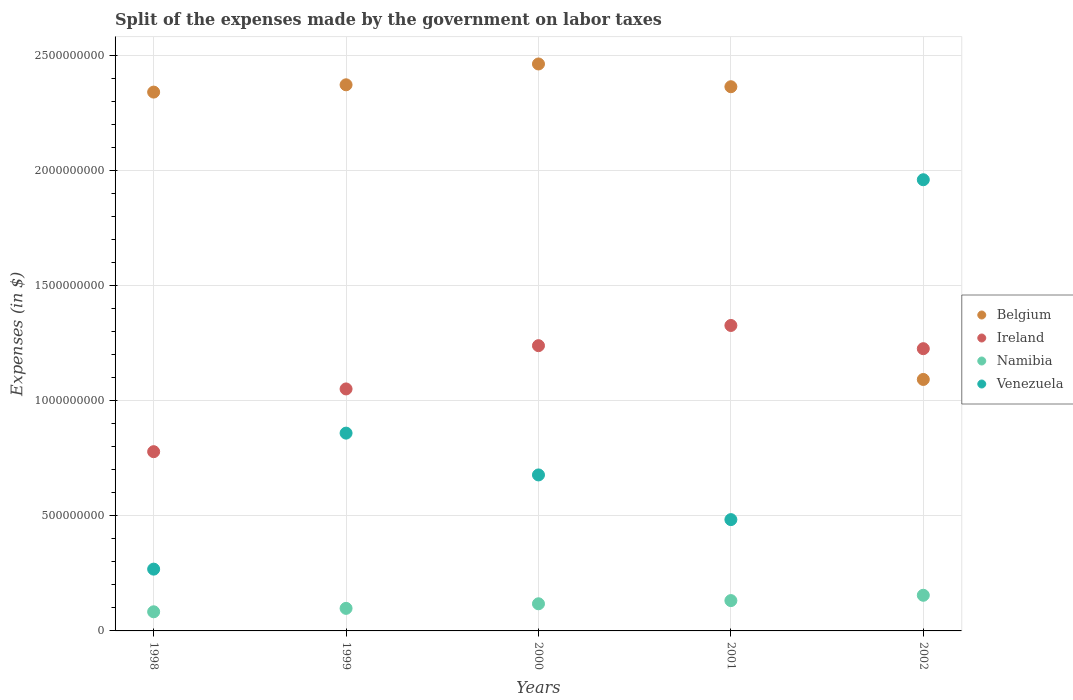Is the number of dotlines equal to the number of legend labels?
Offer a terse response. Yes. What is the expenses made by the government on labor taxes in Ireland in 2002?
Your answer should be compact. 1.23e+09. Across all years, what is the maximum expenses made by the government on labor taxes in Ireland?
Provide a short and direct response. 1.33e+09. Across all years, what is the minimum expenses made by the government on labor taxes in Venezuela?
Provide a succinct answer. 2.68e+08. In which year was the expenses made by the government on labor taxes in Belgium minimum?
Offer a terse response. 2002. What is the total expenses made by the government on labor taxes in Namibia in the graph?
Provide a succinct answer. 5.86e+08. What is the difference between the expenses made by the government on labor taxes in Belgium in 2000 and that in 2001?
Offer a terse response. 9.89e+07. What is the difference between the expenses made by the government on labor taxes in Venezuela in 2002 and the expenses made by the government on labor taxes in Ireland in 1999?
Ensure brevity in your answer.  9.09e+08. What is the average expenses made by the government on labor taxes in Ireland per year?
Offer a very short reply. 1.12e+09. In the year 2002, what is the difference between the expenses made by the government on labor taxes in Ireland and expenses made by the government on labor taxes in Venezuela?
Provide a short and direct response. -7.34e+08. In how many years, is the expenses made by the government on labor taxes in Ireland greater than 100000000 $?
Offer a terse response. 5. What is the ratio of the expenses made by the government on labor taxes in Belgium in 1998 to that in 2000?
Give a very brief answer. 0.95. What is the difference between the highest and the second highest expenses made by the government on labor taxes in Ireland?
Keep it short and to the point. 8.78e+07. What is the difference between the highest and the lowest expenses made by the government on labor taxes in Ireland?
Make the answer very short. 5.48e+08. In how many years, is the expenses made by the government on labor taxes in Namibia greater than the average expenses made by the government on labor taxes in Namibia taken over all years?
Your response must be concise. 3. Is the sum of the expenses made by the government on labor taxes in Belgium in 2001 and 2002 greater than the maximum expenses made by the government on labor taxes in Venezuela across all years?
Make the answer very short. Yes. Is it the case that in every year, the sum of the expenses made by the government on labor taxes in Belgium and expenses made by the government on labor taxes in Namibia  is greater than the sum of expenses made by the government on labor taxes in Venezuela and expenses made by the government on labor taxes in Ireland?
Offer a terse response. Yes. Does the expenses made by the government on labor taxes in Venezuela monotonically increase over the years?
Provide a succinct answer. No. Is the expenses made by the government on labor taxes in Ireland strictly less than the expenses made by the government on labor taxes in Belgium over the years?
Ensure brevity in your answer.  No. How many dotlines are there?
Provide a succinct answer. 4. Does the graph contain grids?
Give a very brief answer. Yes. Where does the legend appear in the graph?
Make the answer very short. Center right. What is the title of the graph?
Your answer should be very brief. Split of the expenses made by the government on labor taxes. What is the label or title of the X-axis?
Keep it short and to the point. Years. What is the label or title of the Y-axis?
Your answer should be compact. Expenses (in $). What is the Expenses (in $) of Belgium in 1998?
Provide a succinct answer. 2.34e+09. What is the Expenses (in $) of Ireland in 1998?
Give a very brief answer. 7.79e+08. What is the Expenses (in $) in Namibia in 1998?
Keep it short and to the point. 8.31e+07. What is the Expenses (in $) of Venezuela in 1998?
Give a very brief answer. 2.68e+08. What is the Expenses (in $) in Belgium in 1999?
Make the answer very short. 2.37e+09. What is the Expenses (in $) of Ireland in 1999?
Provide a short and direct response. 1.05e+09. What is the Expenses (in $) in Namibia in 1999?
Make the answer very short. 9.80e+07. What is the Expenses (in $) in Venezuela in 1999?
Ensure brevity in your answer.  8.59e+08. What is the Expenses (in $) in Belgium in 2000?
Ensure brevity in your answer.  2.46e+09. What is the Expenses (in $) of Ireland in 2000?
Make the answer very short. 1.24e+09. What is the Expenses (in $) in Namibia in 2000?
Offer a very short reply. 1.18e+08. What is the Expenses (in $) in Venezuela in 2000?
Give a very brief answer. 6.78e+08. What is the Expenses (in $) of Belgium in 2001?
Provide a succinct answer. 2.36e+09. What is the Expenses (in $) in Ireland in 2001?
Ensure brevity in your answer.  1.33e+09. What is the Expenses (in $) in Namibia in 2001?
Your answer should be very brief. 1.32e+08. What is the Expenses (in $) in Venezuela in 2001?
Provide a succinct answer. 4.84e+08. What is the Expenses (in $) of Belgium in 2002?
Offer a very short reply. 1.09e+09. What is the Expenses (in $) in Ireland in 2002?
Your answer should be very brief. 1.23e+09. What is the Expenses (in $) of Namibia in 2002?
Your response must be concise. 1.55e+08. What is the Expenses (in $) in Venezuela in 2002?
Make the answer very short. 1.96e+09. Across all years, what is the maximum Expenses (in $) of Belgium?
Provide a short and direct response. 2.46e+09. Across all years, what is the maximum Expenses (in $) of Ireland?
Your answer should be very brief. 1.33e+09. Across all years, what is the maximum Expenses (in $) in Namibia?
Provide a short and direct response. 1.55e+08. Across all years, what is the maximum Expenses (in $) in Venezuela?
Offer a terse response. 1.96e+09. Across all years, what is the minimum Expenses (in $) in Belgium?
Your answer should be compact. 1.09e+09. Across all years, what is the minimum Expenses (in $) in Ireland?
Your answer should be compact. 7.79e+08. Across all years, what is the minimum Expenses (in $) in Namibia?
Provide a short and direct response. 8.31e+07. Across all years, what is the minimum Expenses (in $) of Venezuela?
Provide a short and direct response. 2.68e+08. What is the total Expenses (in $) in Belgium in the graph?
Provide a short and direct response. 1.06e+1. What is the total Expenses (in $) in Ireland in the graph?
Your answer should be compact. 5.62e+09. What is the total Expenses (in $) in Namibia in the graph?
Your response must be concise. 5.86e+08. What is the total Expenses (in $) in Venezuela in the graph?
Give a very brief answer. 4.25e+09. What is the difference between the Expenses (in $) in Belgium in 1998 and that in 1999?
Make the answer very short. -3.17e+07. What is the difference between the Expenses (in $) in Ireland in 1998 and that in 1999?
Make the answer very short. -2.73e+08. What is the difference between the Expenses (in $) in Namibia in 1998 and that in 1999?
Make the answer very short. -1.49e+07. What is the difference between the Expenses (in $) of Venezuela in 1998 and that in 1999?
Ensure brevity in your answer.  -5.91e+08. What is the difference between the Expenses (in $) of Belgium in 1998 and that in 2000?
Keep it short and to the point. -1.22e+08. What is the difference between the Expenses (in $) in Ireland in 1998 and that in 2000?
Your answer should be compact. -4.61e+08. What is the difference between the Expenses (in $) of Namibia in 1998 and that in 2000?
Offer a very short reply. -3.48e+07. What is the difference between the Expenses (in $) of Venezuela in 1998 and that in 2000?
Make the answer very short. -4.09e+08. What is the difference between the Expenses (in $) in Belgium in 1998 and that in 2001?
Give a very brief answer. -2.33e+07. What is the difference between the Expenses (in $) of Ireland in 1998 and that in 2001?
Your answer should be compact. -5.48e+08. What is the difference between the Expenses (in $) of Namibia in 1998 and that in 2001?
Provide a succinct answer. -4.86e+07. What is the difference between the Expenses (in $) of Venezuela in 1998 and that in 2001?
Give a very brief answer. -2.15e+08. What is the difference between the Expenses (in $) in Belgium in 1998 and that in 2002?
Keep it short and to the point. 1.25e+09. What is the difference between the Expenses (in $) in Ireland in 1998 and that in 2002?
Ensure brevity in your answer.  -4.47e+08. What is the difference between the Expenses (in $) of Namibia in 1998 and that in 2002?
Your answer should be compact. -7.17e+07. What is the difference between the Expenses (in $) in Venezuela in 1998 and that in 2002?
Provide a short and direct response. -1.69e+09. What is the difference between the Expenses (in $) in Belgium in 1999 and that in 2000?
Provide a succinct answer. -9.05e+07. What is the difference between the Expenses (in $) in Ireland in 1999 and that in 2000?
Ensure brevity in your answer.  -1.88e+08. What is the difference between the Expenses (in $) in Namibia in 1999 and that in 2000?
Provide a succinct answer. -1.99e+07. What is the difference between the Expenses (in $) of Venezuela in 1999 and that in 2000?
Ensure brevity in your answer.  1.82e+08. What is the difference between the Expenses (in $) in Belgium in 1999 and that in 2001?
Ensure brevity in your answer.  8.40e+06. What is the difference between the Expenses (in $) of Ireland in 1999 and that in 2001?
Make the answer very short. -2.76e+08. What is the difference between the Expenses (in $) of Namibia in 1999 and that in 2001?
Keep it short and to the point. -3.38e+07. What is the difference between the Expenses (in $) in Venezuela in 1999 and that in 2001?
Your answer should be very brief. 3.76e+08. What is the difference between the Expenses (in $) in Belgium in 1999 and that in 2002?
Provide a short and direct response. 1.28e+09. What is the difference between the Expenses (in $) in Ireland in 1999 and that in 2002?
Offer a terse response. -1.75e+08. What is the difference between the Expenses (in $) of Namibia in 1999 and that in 2002?
Offer a terse response. -5.68e+07. What is the difference between the Expenses (in $) of Venezuela in 1999 and that in 2002?
Provide a short and direct response. -1.10e+09. What is the difference between the Expenses (in $) in Belgium in 2000 and that in 2001?
Provide a succinct answer. 9.89e+07. What is the difference between the Expenses (in $) of Ireland in 2000 and that in 2001?
Offer a terse response. -8.78e+07. What is the difference between the Expenses (in $) of Namibia in 2000 and that in 2001?
Ensure brevity in your answer.  -1.39e+07. What is the difference between the Expenses (in $) in Venezuela in 2000 and that in 2001?
Keep it short and to the point. 1.94e+08. What is the difference between the Expenses (in $) of Belgium in 2000 and that in 2002?
Your answer should be very brief. 1.37e+09. What is the difference between the Expenses (in $) in Ireland in 2000 and that in 2002?
Give a very brief answer. 1.31e+07. What is the difference between the Expenses (in $) of Namibia in 2000 and that in 2002?
Offer a very short reply. -3.70e+07. What is the difference between the Expenses (in $) of Venezuela in 2000 and that in 2002?
Keep it short and to the point. -1.28e+09. What is the difference between the Expenses (in $) in Belgium in 2001 and that in 2002?
Give a very brief answer. 1.27e+09. What is the difference between the Expenses (in $) of Ireland in 2001 and that in 2002?
Provide a succinct answer. 1.01e+08. What is the difference between the Expenses (in $) in Namibia in 2001 and that in 2002?
Make the answer very short. -2.31e+07. What is the difference between the Expenses (in $) of Venezuela in 2001 and that in 2002?
Offer a terse response. -1.48e+09. What is the difference between the Expenses (in $) of Belgium in 1998 and the Expenses (in $) of Ireland in 1999?
Your answer should be very brief. 1.29e+09. What is the difference between the Expenses (in $) in Belgium in 1998 and the Expenses (in $) in Namibia in 1999?
Your answer should be very brief. 2.24e+09. What is the difference between the Expenses (in $) in Belgium in 1998 and the Expenses (in $) in Venezuela in 1999?
Provide a short and direct response. 1.48e+09. What is the difference between the Expenses (in $) in Ireland in 1998 and the Expenses (in $) in Namibia in 1999?
Ensure brevity in your answer.  6.81e+08. What is the difference between the Expenses (in $) in Ireland in 1998 and the Expenses (in $) in Venezuela in 1999?
Provide a succinct answer. -8.06e+07. What is the difference between the Expenses (in $) of Namibia in 1998 and the Expenses (in $) of Venezuela in 1999?
Your answer should be compact. -7.76e+08. What is the difference between the Expenses (in $) of Belgium in 1998 and the Expenses (in $) of Ireland in 2000?
Make the answer very short. 1.10e+09. What is the difference between the Expenses (in $) of Belgium in 1998 and the Expenses (in $) of Namibia in 2000?
Your response must be concise. 2.22e+09. What is the difference between the Expenses (in $) in Belgium in 1998 and the Expenses (in $) in Venezuela in 2000?
Make the answer very short. 1.66e+09. What is the difference between the Expenses (in $) of Ireland in 1998 and the Expenses (in $) of Namibia in 2000?
Your answer should be very brief. 6.61e+08. What is the difference between the Expenses (in $) in Ireland in 1998 and the Expenses (in $) in Venezuela in 2000?
Your answer should be very brief. 1.01e+08. What is the difference between the Expenses (in $) of Namibia in 1998 and the Expenses (in $) of Venezuela in 2000?
Offer a very short reply. -5.95e+08. What is the difference between the Expenses (in $) in Belgium in 1998 and the Expenses (in $) in Ireland in 2001?
Your answer should be very brief. 1.01e+09. What is the difference between the Expenses (in $) of Belgium in 1998 and the Expenses (in $) of Namibia in 2001?
Your answer should be very brief. 2.21e+09. What is the difference between the Expenses (in $) in Belgium in 1998 and the Expenses (in $) in Venezuela in 2001?
Offer a very short reply. 1.86e+09. What is the difference between the Expenses (in $) in Ireland in 1998 and the Expenses (in $) in Namibia in 2001?
Your answer should be compact. 6.47e+08. What is the difference between the Expenses (in $) in Ireland in 1998 and the Expenses (in $) in Venezuela in 2001?
Offer a very short reply. 2.95e+08. What is the difference between the Expenses (in $) in Namibia in 1998 and the Expenses (in $) in Venezuela in 2001?
Ensure brevity in your answer.  -4.00e+08. What is the difference between the Expenses (in $) in Belgium in 1998 and the Expenses (in $) in Ireland in 2002?
Offer a terse response. 1.11e+09. What is the difference between the Expenses (in $) in Belgium in 1998 and the Expenses (in $) in Namibia in 2002?
Keep it short and to the point. 2.19e+09. What is the difference between the Expenses (in $) in Belgium in 1998 and the Expenses (in $) in Venezuela in 2002?
Your answer should be very brief. 3.81e+08. What is the difference between the Expenses (in $) of Ireland in 1998 and the Expenses (in $) of Namibia in 2002?
Ensure brevity in your answer.  6.24e+08. What is the difference between the Expenses (in $) of Ireland in 1998 and the Expenses (in $) of Venezuela in 2002?
Provide a short and direct response. -1.18e+09. What is the difference between the Expenses (in $) in Namibia in 1998 and the Expenses (in $) in Venezuela in 2002?
Offer a very short reply. -1.88e+09. What is the difference between the Expenses (in $) in Belgium in 1999 and the Expenses (in $) in Ireland in 2000?
Offer a terse response. 1.13e+09. What is the difference between the Expenses (in $) in Belgium in 1999 and the Expenses (in $) in Namibia in 2000?
Keep it short and to the point. 2.25e+09. What is the difference between the Expenses (in $) in Belgium in 1999 and the Expenses (in $) in Venezuela in 2000?
Give a very brief answer. 1.69e+09. What is the difference between the Expenses (in $) of Ireland in 1999 and the Expenses (in $) of Namibia in 2000?
Ensure brevity in your answer.  9.33e+08. What is the difference between the Expenses (in $) of Ireland in 1999 and the Expenses (in $) of Venezuela in 2000?
Offer a terse response. 3.74e+08. What is the difference between the Expenses (in $) in Namibia in 1999 and the Expenses (in $) in Venezuela in 2000?
Make the answer very short. -5.80e+08. What is the difference between the Expenses (in $) of Belgium in 1999 and the Expenses (in $) of Ireland in 2001?
Offer a very short reply. 1.05e+09. What is the difference between the Expenses (in $) of Belgium in 1999 and the Expenses (in $) of Namibia in 2001?
Keep it short and to the point. 2.24e+09. What is the difference between the Expenses (in $) of Belgium in 1999 and the Expenses (in $) of Venezuela in 2001?
Ensure brevity in your answer.  1.89e+09. What is the difference between the Expenses (in $) in Ireland in 1999 and the Expenses (in $) in Namibia in 2001?
Make the answer very short. 9.20e+08. What is the difference between the Expenses (in $) of Ireland in 1999 and the Expenses (in $) of Venezuela in 2001?
Offer a terse response. 5.68e+08. What is the difference between the Expenses (in $) of Namibia in 1999 and the Expenses (in $) of Venezuela in 2001?
Make the answer very short. -3.86e+08. What is the difference between the Expenses (in $) in Belgium in 1999 and the Expenses (in $) in Ireland in 2002?
Provide a short and direct response. 1.15e+09. What is the difference between the Expenses (in $) in Belgium in 1999 and the Expenses (in $) in Namibia in 2002?
Offer a terse response. 2.22e+09. What is the difference between the Expenses (in $) of Belgium in 1999 and the Expenses (in $) of Venezuela in 2002?
Your answer should be very brief. 4.12e+08. What is the difference between the Expenses (in $) in Ireland in 1999 and the Expenses (in $) in Namibia in 2002?
Your response must be concise. 8.96e+08. What is the difference between the Expenses (in $) of Ireland in 1999 and the Expenses (in $) of Venezuela in 2002?
Your answer should be very brief. -9.09e+08. What is the difference between the Expenses (in $) in Namibia in 1999 and the Expenses (in $) in Venezuela in 2002?
Your answer should be compact. -1.86e+09. What is the difference between the Expenses (in $) in Belgium in 2000 and the Expenses (in $) in Ireland in 2001?
Offer a terse response. 1.14e+09. What is the difference between the Expenses (in $) in Belgium in 2000 and the Expenses (in $) in Namibia in 2001?
Make the answer very short. 2.33e+09. What is the difference between the Expenses (in $) of Belgium in 2000 and the Expenses (in $) of Venezuela in 2001?
Your answer should be compact. 1.98e+09. What is the difference between the Expenses (in $) of Ireland in 2000 and the Expenses (in $) of Namibia in 2001?
Make the answer very short. 1.11e+09. What is the difference between the Expenses (in $) of Ireland in 2000 and the Expenses (in $) of Venezuela in 2001?
Keep it short and to the point. 7.56e+08. What is the difference between the Expenses (in $) of Namibia in 2000 and the Expenses (in $) of Venezuela in 2001?
Your answer should be compact. -3.66e+08. What is the difference between the Expenses (in $) of Belgium in 2000 and the Expenses (in $) of Ireland in 2002?
Offer a terse response. 1.24e+09. What is the difference between the Expenses (in $) in Belgium in 2000 and the Expenses (in $) in Namibia in 2002?
Make the answer very short. 2.31e+09. What is the difference between the Expenses (in $) of Belgium in 2000 and the Expenses (in $) of Venezuela in 2002?
Your answer should be compact. 5.03e+08. What is the difference between the Expenses (in $) of Ireland in 2000 and the Expenses (in $) of Namibia in 2002?
Give a very brief answer. 1.08e+09. What is the difference between the Expenses (in $) of Ireland in 2000 and the Expenses (in $) of Venezuela in 2002?
Your answer should be very brief. -7.21e+08. What is the difference between the Expenses (in $) of Namibia in 2000 and the Expenses (in $) of Venezuela in 2002?
Your response must be concise. -1.84e+09. What is the difference between the Expenses (in $) of Belgium in 2001 and the Expenses (in $) of Ireland in 2002?
Give a very brief answer. 1.14e+09. What is the difference between the Expenses (in $) of Belgium in 2001 and the Expenses (in $) of Namibia in 2002?
Provide a succinct answer. 2.21e+09. What is the difference between the Expenses (in $) in Belgium in 2001 and the Expenses (in $) in Venezuela in 2002?
Your answer should be compact. 4.04e+08. What is the difference between the Expenses (in $) in Ireland in 2001 and the Expenses (in $) in Namibia in 2002?
Offer a terse response. 1.17e+09. What is the difference between the Expenses (in $) of Ireland in 2001 and the Expenses (in $) of Venezuela in 2002?
Provide a short and direct response. -6.33e+08. What is the difference between the Expenses (in $) of Namibia in 2001 and the Expenses (in $) of Venezuela in 2002?
Ensure brevity in your answer.  -1.83e+09. What is the average Expenses (in $) in Belgium per year?
Provide a short and direct response. 2.13e+09. What is the average Expenses (in $) of Ireland per year?
Make the answer very short. 1.12e+09. What is the average Expenses (in $) in Namibia per year?
Give a very brief answer. 1.17e+08. What is the average Expenses (in $) in Venezuela per year?
Keep it short and to the point. 8.50e+08. In the year 1998, what is the difference between the Expenses (in $) of Belgium and Expenses (in $) of Ireland?
Your answer should be compact. 1.56e+09. In the year 1998, what is the difference between the Expenses (in $) of Belgium and Expenses (in $) of Namibia?
Your answer should be compact. 2.26e+09. In the year 1998, what is the difference between the Expenses (in $) in Belgium and Expenses (in $) in Venezuela?
Your response must be concise. 2.07e+09. In the year 1998, what is the difference between the Expenses (in $) in Ireland and Expenses (in $) in Namibia?
Offer a very short reply. 6.96e+08. In the year 1998, what is the difference between the Expenses (in $) in Ireland and Expenses (in $) in Venezuela?
Provide a short and direct response. 5.10e+08. In the year 1998, what is the difference between the Expenses (in $) in Namibia and Expenses (in $) in Venezuela?
Give a very brief answer. -1.85e+08. In the year 1999, what is the difference between the Expenses (in $) in Belgium and Expenses (in $) in Ireland?
Ensure brevity in your answer.  1.32e+09. In the year 1999, what is the difference between the Expenses (in $) of Belgium and Expenses (in $) of Namibia?
Give a very brief answer. 2.27e+09. In the year 1999, what is the difference between the Expenses (in $) in Belgium and Expenses (in $) in Venezuela?
Your answer should be compact. 1.51e+09. In the year 1999, what is the difference between the Expenses (in $) of Ireland and Expenses (in $) of Namibia?
Keep it short and to the point. 9.53e+08. In the year 1999, what is the difference between the Expenses (in $) of Ireland and Expenses (in $) of Venezuela?
Make the answer very short. 1.92e+08. In the year 1999, what is the difference between the Expenses (in $) of Namibia and Expenses (in $) of Venezuela?
Offer a very short reply. -7.61e+08. In the year 2000, what is the difference between the Expenses (in $) of Belgium and Expenses (in $) of Ireland?
Make the answer very short. 1.22e+09. In the year 2000, what is the difference between the Expenses (in $) in Belgium and Expenses (in $) in Namibia?
Give a very brief answer. 2.35e+09. In the year 2000, what is the difference between the Expenses (in $) in Belgium and Expenses (in $) in Venezuela?
Offer a terse response. 1.79e+09. In the year 2000, what is the difference between the Expenses (in $) in Ireland and Expenses (in $) in Namibia?
Your answer should be very brief. 1.12e+09. In the year 2000, what is the difference between the Expenses (in $) of Ireland and Expenses (in $) of Venezuela?
Your answer should be very brief. 5.62e+08. In the year 2000, what is the difference between the Expenses (in $) in Namibia and Expenses (in $) in Venezuela?
Keep it short and to the point. -5.60e+08. In the year 2001, what is the difference between the Expenses (in $) in Belgium and Expenses (in $) in Ireland?
Give a very brief answer. 1.04e+09. In the year 2001, what is the difference between the Expenses (in $) in Belgium and Expenses (in $) in Namibia?
Ensure brevity in your answer.  2.23e+09. In the year 2001, what is the difference between the Expenses (in $) in Belgium and Expenses (in $) in Venezuela?
Offer a terse response. 1.88e+09. In the year 2001, what is the difference between the Expenses (in $) in Ireland and Expenses (in $) in Namibia?
Keep it short and to the point. 1.20e+09. In the year 2001, what is the difference between the Expenses (in $) in Ireland and Expenses (in $) in Venezuela?
Provide a succinct answer. 8.43e+08. In the year 2001, what is the difference between the Expenses (in $) of Namibia and Expenses (in $) of Venezuela?
Provide a short and direct response. -3.52e+08. In the year 2002, what is the difference between the Expenses (in $) in Belgium and Expenses (in $) in Ireland?
Your answer should be compact. -1.34e+08. In the year 2002, what is the difference between the Expenses (in $) in Belgium and Expenses (in $) in Namibia?
Keep it short and to the point. 9.38e+08. In the year 2002, what is the difference between the Expenses (in $) in Belgium and Expenses (in $) in Venezuela?
Provide a short and direct response. -8.68e+08. In the year 2002, what is the difference between the Expenses (in $) in Ireland and Expenses (in $) in Namibia?
Provide a short and direct response. 1.07e+09. In the year 2002, what is the difference between the Expenses (in $) of Ireland and Expenses (in $) of Venezuela?
Make the answer very short. -7.34e+08. In the year 2002, what is the difference between the Expenses (in $) in Namibia and Expenses (in $) in Venezuela?
Provide a short and direct response. -1.81e+09. What is the ratio of the Expenses (in $) in Belgium in 1998 to that in 1999?
Provide a short and direct response. 0.99. What is the ratio of the Expenses (in $) of Ireland in 1998 to that in 1999?
Provide a succinct answer. 0.74. What is the ratio of the Expenses (in $) in Namibia in 1998 to that in 1999?
Your answer should be very brief. 0.85. What is the ratio of the Expenses (in $) of Venezuela in 1998 to that in 1999?
Make the answer very short. 0.31. What is the ratio of the Expenses (in $) in Belgium in 1998 to that in 2000?
Provide a short and direct response. 0.95. What is the ratio of the Expenses (in $) in Ireland in 1998 to that in 2000?
Ensure brevity in your answer.  0.63. What is the ratio of the Expenses (in $) of Namibia in 1998 to that in 2000?
Your answer should be compact. 0.7. What is the ratio of the Expenses (in $) in Venezuela in 1998 to that in 2000?
Offer a terse response. 0.4. What is the ratio of the Expenses (in $) in Belgium in 1998 to that in 2001?
Your answer should be compact. 0.99. What is the ratio of the Expenses (in $) of Ireland in 1998 to that in 2001?
Make the answer very short. 0.59. What is the ratio of the Expenses (in $) of Namibia in 1998 to that in 2001?
Your response must be concise. 0.63. What is the ratio of the Expenses (in $) in Venezuela in 1998 to that in 2001?
Ensure brevity in your answer.  0.56. What is the ratio of the Expenses (in $) in Belgium in 1998 to that in 2002?
Make the answer very short. 2.14. What is the ratio of the Expenses (in $) in Ireland in 1998 to that in 2002?
Your answer should be very brief. 0.64. What is the ratio of the Expenses (in $) of Namibia in 1998 to that in 2002?
Provide a succinct answer. 0.54. What is the ratio of the Expenses (in $) in Venezuela in 1998 to that in 2002?
Make the answer very short. 0.14. What is the ratio of the Expenses (in $) of Belgium in 1999 to that in 2000?
Your answer should be compact. 0.96. What is the ratio of the Expenses (in $) in Ireland in 1999 to that in 2000?
Provide a succinct answer. 0.85. What is the ratio of the Expenses (in $) of Namibia in 1999 to that in 2000?
Your answer should be very brief. 0.83. What is the ratio of the Expenses (in $) in Venezuela in 1999 to that in 2000?
Give a very brief answer. 1.27. What is the ratio of the Expenses (in $) of Ireland in 1999 to that in 2001?
Provide a short and direct response. 0.79. What is the ratio of the Expenses (in $) of Namibia in 1999 to that in 2001?
Your answer should be very brief. 0.74. What is the ratio of the Expenses (in $) of Venezuela in 1999 to that in 2001?
Provide a short and direct response. 1.78. What is the ratio of the Expenses (in $) of Belgium in 1999 to that in 2002?
Offer a terse response. 2.17. What is the ratio of the Expenses (in $) of Ireland in 1999 to that in 2002?
Provide a succinct answer. 0.86. What is the ratio of the Expenses (in $) in Namibia in 1999 to that in 2002?
Give a very brief answer. 0.63. What is the ratio of the Expenses (in $) in Venezuela in 1999 to that in 2002?
Keep it short and to the point. 0.44. What is the ratio of the Expenses (in $) of Belgium in 2000 to that in 2001?
Your response must be concise. 1.04. What is the ratio of the Expenses (in $) of Ireland in 2000 to that in 2001?
Your answer should be very brief. 0.93. What is the ratio of the Expenses (in $) of Namibia in 2000 to that in 2001?
Ensure brevity in your answer.  0.89. What is the ratio of the Expenses (in $) of Venezuela in 2000 to that in 2001?
Your answer should be very brief. 1.4. What is the ratio of the Expenses (in $) of Belgium in 2000 to that in 2002?
Give a very brief answer. 2.25. What is the ratio of the Expenses (in $) in Ireland in 2000 to that in 2002?
Ensure brevity in your answer.  1.01. What is the ratio of the Expenses (in $) of Namibia in 2000 to that in 2002?
Your answer should be very brief. 0.76. What is the ratio of the Expenses (in $) of Venezuela in 2000 to that in 2002?
Your response must be concise. 0.35. What is the ratio of the Expenses (in $) of Belgium in 2001 to that in 2002?
Keep it short and to the point. 2.16. What is the ratio of the Expenses (in $) in Ireland in 2001 to that in 2002?
Provide a short and direct response. 1.08. What is the ratio of the Expenses (in $) of Namibia in 2001 to that in 2002?
Offer a terse response. 0.85. What is the ratio of the Expenses (in $) in Venezuela in 2001 to that in 2002?
Make the answer very short. 0.25. What is the difference between the highest and the second highest Expenses (in $) in Belgium?
Your answer should be very brief. 9.05e+07. What is the difference between the highest and the second highest Expenses (in $) in Ireland?
Offer a very short reply. 8.78e+07. What is the difference between the highest and the second highest Expenses (in $) of Namibia?
Give a very brief answer. 2.31e+07. What is the difference between the highest and the second highest Expenses (in $) in Venezuela?
Offer a very short reply. 1.10e+09. What is the difference between the highest and the lowest Expenses (in $) of Belgium?
Offer a very short reply. 1.37e+09. What is the difference between the highest and the lowest Expenses (in $) of Ireland?
Make the answer very short. 5.48e+08. What is the difference between the highest and the lowest Expenses (in $) in Namibia?
Offer a terse response. 7.17e+07. What is the difference between the highest and the lowest Expenses (in $) of Venezuela?
Offer a terse response. 1.69e+09. 